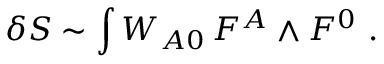Convert formula to latex. <formula><loc_0><loc_0><loc_500><loc_500>\delta S \sim \int W _ { A 0 } \, F ^ { A } \wedge F ^ { 0 } \ .</formula> 